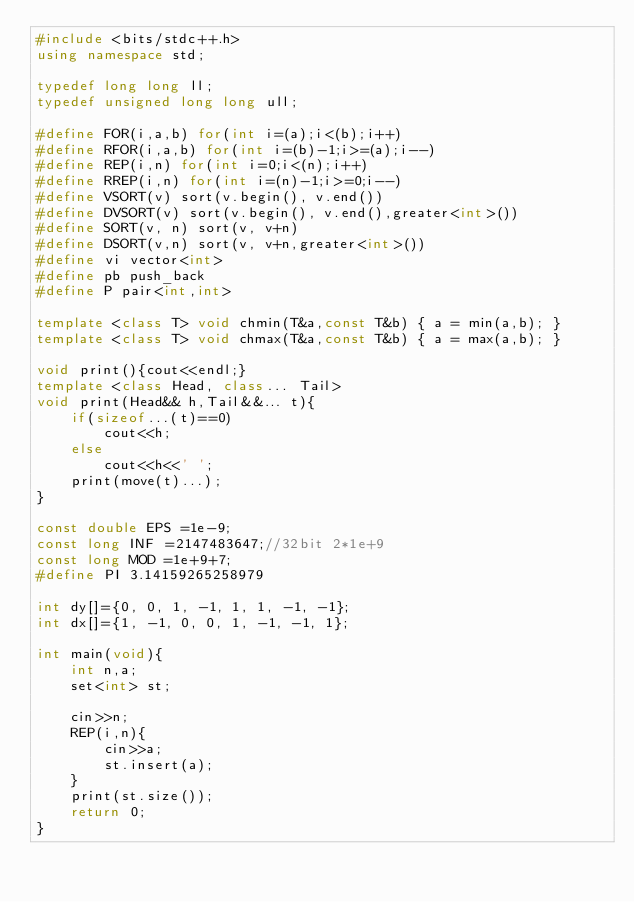<code> <loc_0><loc_0><loc_500><loc_500><_C++_>#include <bits/stdc++.h>
using namespace std;
 
typedef long long ll;
typedef unsigned long long ull;
 
#define FOR(i,a,b) for(int i=(a);i<(b);i++)
#define RFOR(i,a,b) for(int i=(b)-1;i>=(a);i--)
#define REP(i,n) for(int i=0;i<(n);i++)
#define RREP(i,n) for(int i=(n)-1;i>=0;i--)
#define VSORT(v) sort(v.begin(), v.end())
#define DVSORT(v) sort(v.begin(), v.end(),greater<int>())
#define SORT(v, n) sort(v, v+n)
#define DSORT(v,n) sort(v, v+n,greater<int>())
#define vi vector<int>
#define pb push_back
#define P pair<int,int>
 
template <class T> void chmin(T&a,const T&b) { a = min(a,b); }
template <class T> void chmax(T&a,const T&b) { a = max(a,b); }
 
void print(){cout<<endl;}
template <class Head, class... Tail>
void print(Head&& h,Tail&&... t){ 
	if(sizeof...(t)==0)
		cout<<h;
	else
		cout<<h<<' ';
	print(move(t)...);
}
 
const double EPS =1e-9;
const long INF =2147483647;//32bit 2*1e+9
const long MOD =1e+9+7;
#define PI 3.14159265258979
 
int dy[]={0, 0, 1, -1, 1, 1, -1, -1};
int dx[]={1, -1, 0, 0, 1, -1, -1, 1};

int main(void){
	int n,a;
	set<int> st;
	
	cin>>n;
	REP(i,n){
		cin>>a;
		st.insert(a);
	}
	print(st.size());
	return 0;
}
</code> 